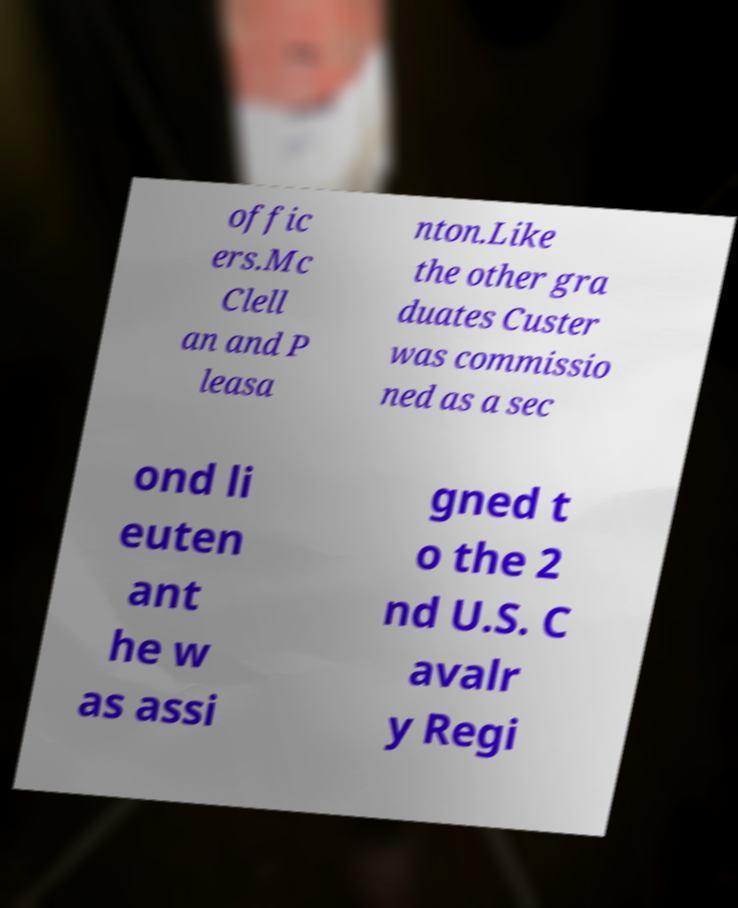Can you accurately transcribe the text from the provided image for me? offic ers.Mc Clell an and P leasa nton.Like the other gra duates Custer was commissio ned as a sec ond li euten ant he w as assi gned t o the 2 nd U.S. C avalr y Regi 